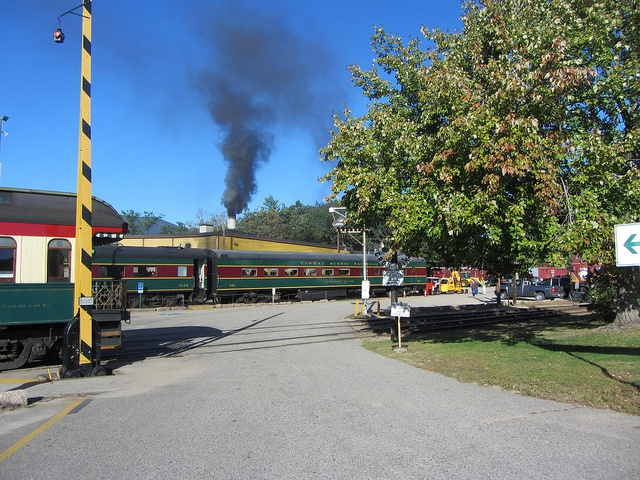Describe the objects in this image and their specific colors. I can see train in blue, black, gray, teal, and beige tones, train in blue, black, teal, gray, and maroon tones, truck in blue, gray, darkblue, and black tones, car in blue, black, gray, navy, and purple tones, and car in blue, black, red, maroon, and gray tones in this image. 